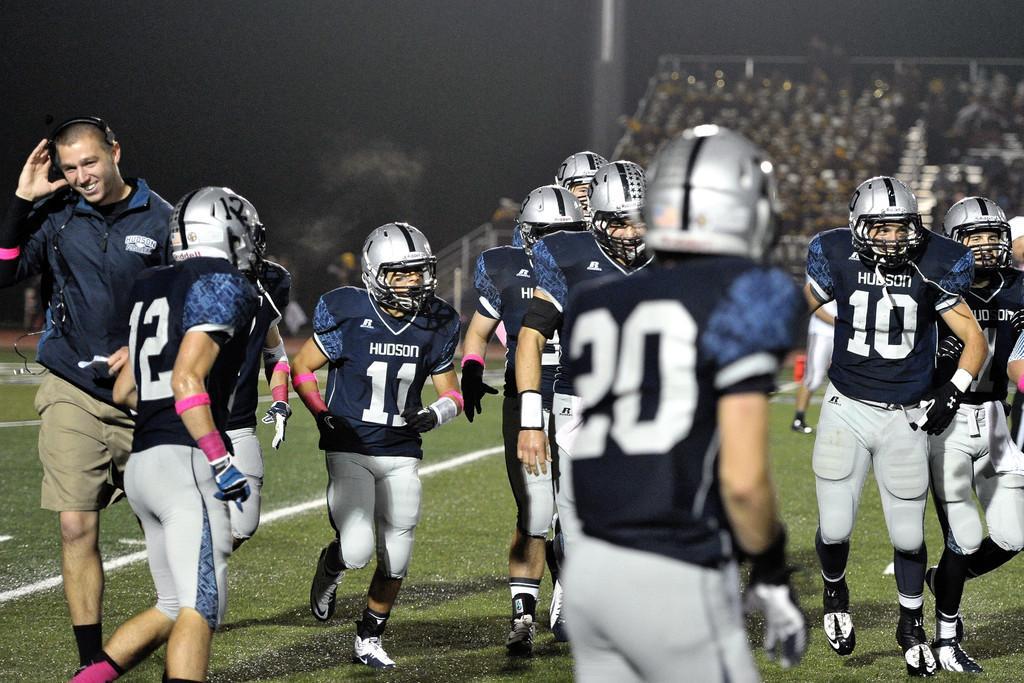How would you summarize this image in a sentence or two? In this image I can see group of people standing. In front the person is wearing black and gray color dress and gray color helmet. In the background I can see few people sitting and I can also see the pole. 